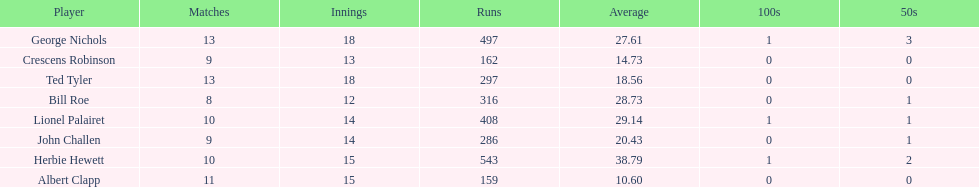Name a player that play in no more than 13 innings. Bill Roe. 